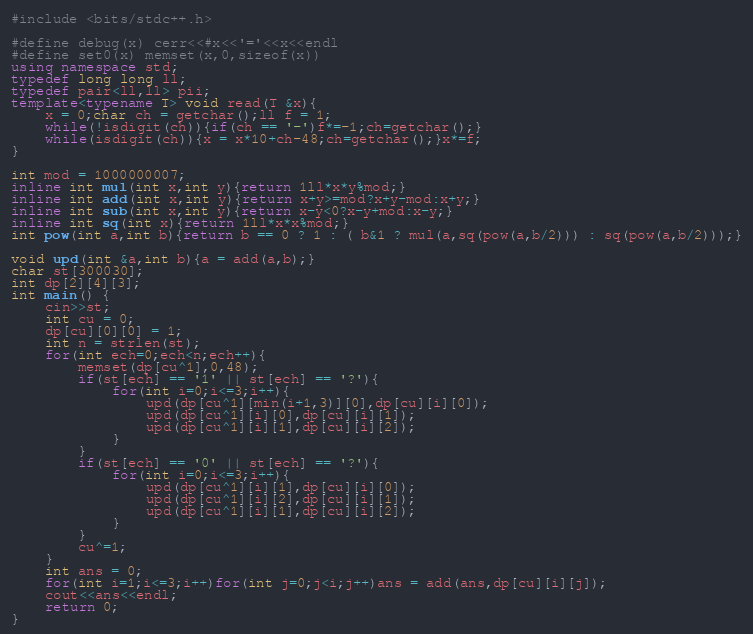<code> <loc_0><loc_0><loc_500><loc_500><_C++_>#include <bits/stdc++.h>

#define debug(x) cerr<<#x<<'='<<x<<endl
#define set0(x) memset(x,0,sizeof(x))
using namespace std;
typedef long long ll;
typedef pair<ll,ll> pii;
template<typename T> void read(T &x){
	x = 0;char ch = getchar();ll f = 1;
	while(!isdigit(ch)){if(ch == '-')f*=-1;ch=getchar();}
	while(isdigit(ch)){x = x*10+ch-48;ch=getchar();}x*=f;
}

int mod = 1000000007;
inline int mul(int x,int y){return 1ll*x*y%mod;}
inline int add(int x,int y){return x+y>=mod?x+y-mod:x+y;}
inline int sub(int x,int y){return x-y<0?x-y+mod:x-y;}
inline int sq(int x){return 1ll*x*x%mod;}
int pow(int a,int b){return b == 0 ? 1 : ( b&1 ? mul(a,sq(pow(a,b/2))) : sq(pow(a,b/2)));}

void upd(int &a,int b){a = add(a,b);}
char st[300030];
int dp[2][4][3];
int main() {
	cin>>st;
	int cu = 0;
	dp[cu][0][0] = 1;
	int n = strlen(st);
	for(int ech=0;ech<n;ech++){
		memset(dp[cu^1],0,48);
		if(st[ech] == '1' || st[ech] == '?'){
			for(int i=0;i<=3;i++){
				upd(dp[cu^1][min(i+1,3)][0],dp[cu][i][0]);
				upd(dp[cu^1][i][0],dp[cu][i][1]);
				upd(dp[cu^1][i][1],dp[cu][i][2]);
			}
		}
		if(st[ech] == '0' || st[ech] == '?'){
			for(int i=0;i<=3;i++){
				upd(dp[cu^1][i][1],dp[cu][i][0]);
				upd(dp[cu^1][i][2],dp[cu][i][1]);
				upd(dp[cu^1][i][1],dp[cu][i][2]);
			}
		}
		cu^=1;
	}
	int ans = 0;
	for(int i=1;i<=3;i++)for(int j=0;j<i;j++)ans = add(ans,dp[cu][i][j]);
	cout<<ans<<endl;
	return 0;
}
</code> 